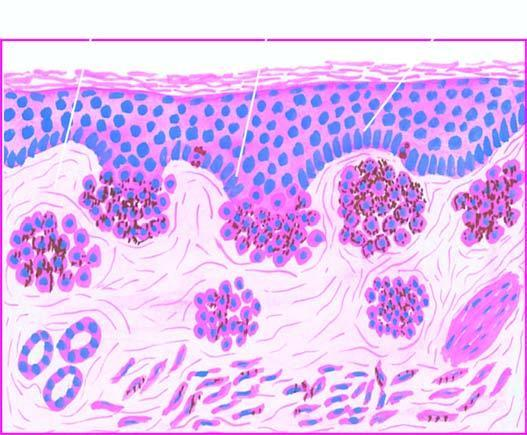do these cells contain coarse, granular, brown-black melanin pigment?
Answer the question using a single word or phrase. Yes 